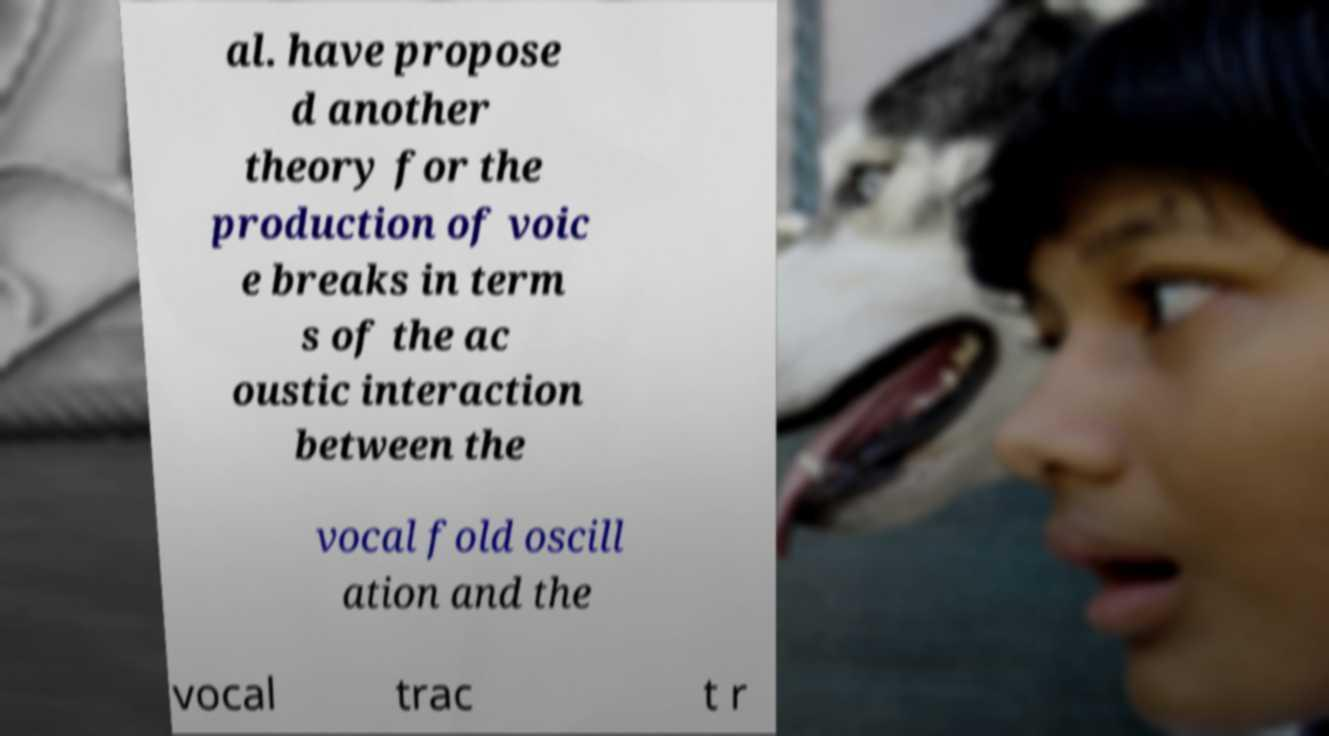Could you assist in decoding the text presented in this image and type it out clearly? al. have propose d another theory for the production of voic e breaks in term s of the ac oustic interaction between the vocal fold oscill ation and the vocal trac t r 